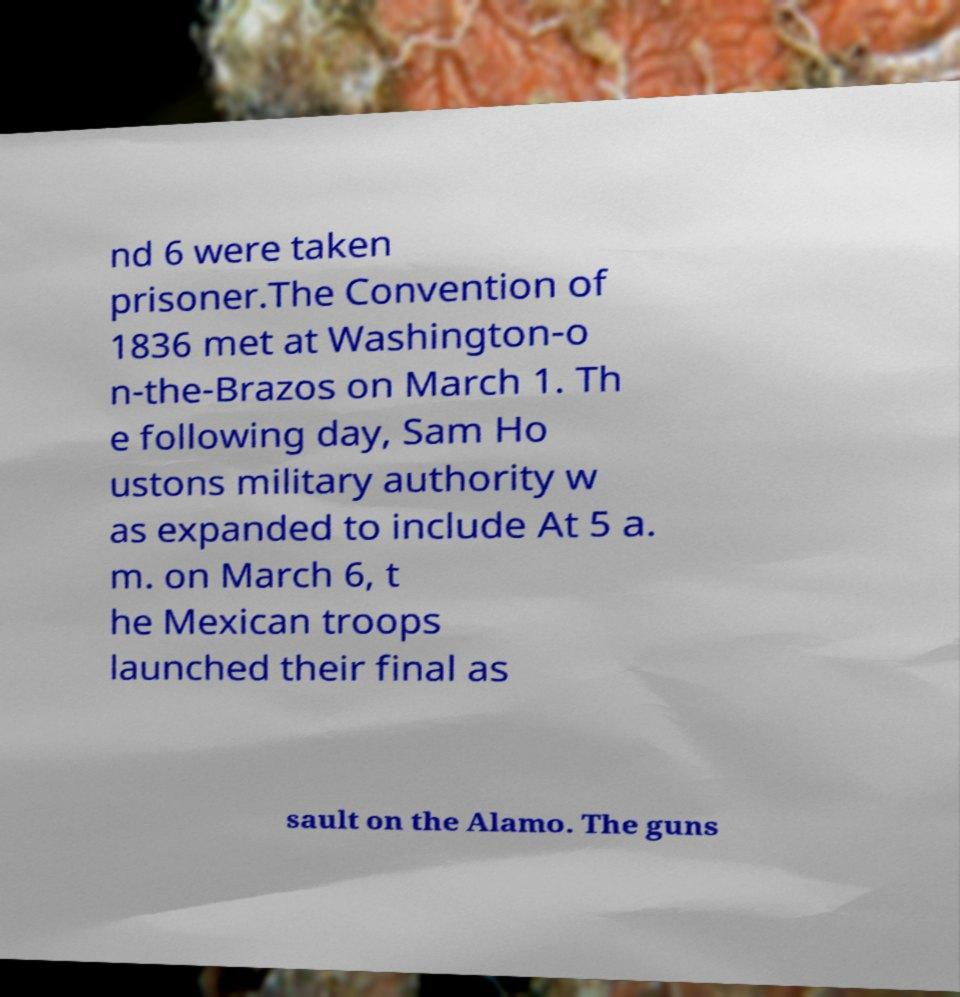Can you accurately transcribe the text from the provided image for me? nd 6 were taken prisoner.The Convention of 1836 met at Washington-o n-the-Brazos on March 1. Th e following day, Sam Ho ustons military authority w as expanded to include At 5 a. m. on March 6, t he Mexican troops launched their final as sault on the Alamo. The guns 